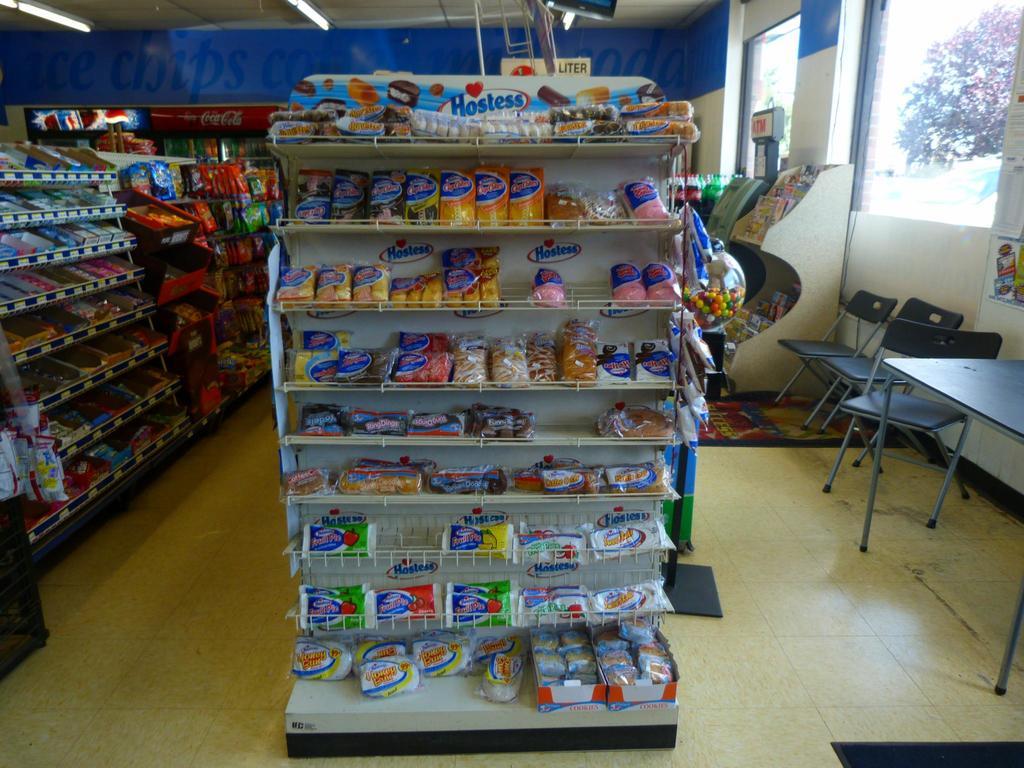What brand are these snack cakes?
Ensure brevity in your answer.  Hostess. What soda brand is on the cooler along the back wall?
Give a very brief answer. Coca cola. 